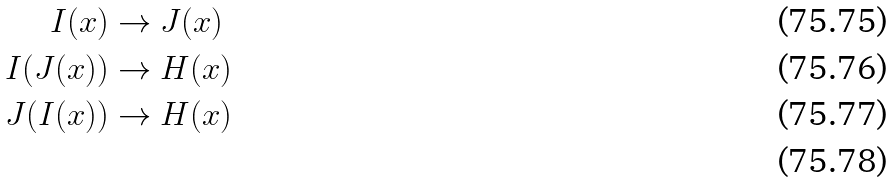Convert formula to latex. <formula><loc_0><loc_0><loc_500><loc_500>I ( x ) & \to J ( x ) \\ I ( J ( x ) ) & \to H ( x ) \\ J ( I ( x ) ) & \to H ( x ) \\</formula> 